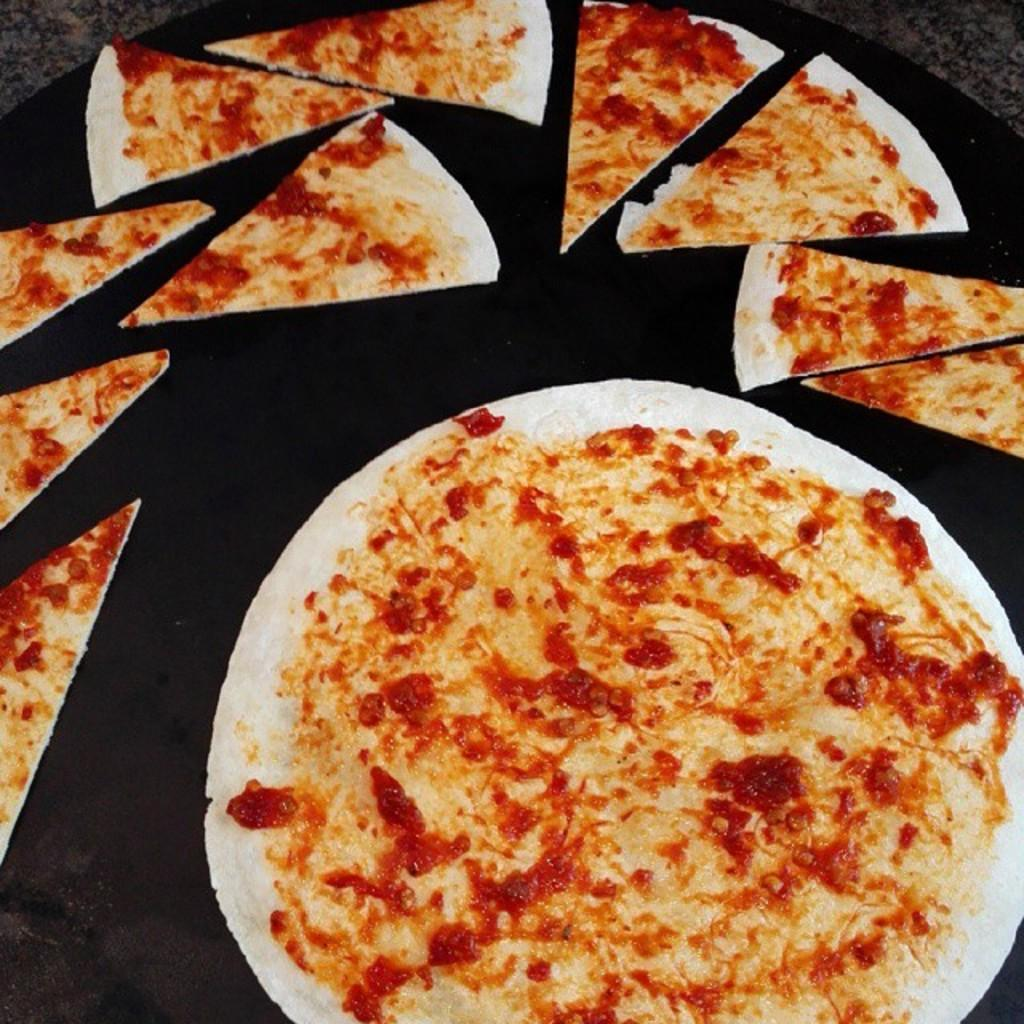What type of food is shown in the image? There is a pizza in the image. How is the pizza presented in the image? The pizza is shown in slices in the image. On what surface are the pizza and its slices placed? The pizza and its slices are placed on a surface in the image. What committee is responsible for the pizza's taste in the image? There is no committee mentioned or implied in the image, and the taste of the pizza is not a subject of the image. 